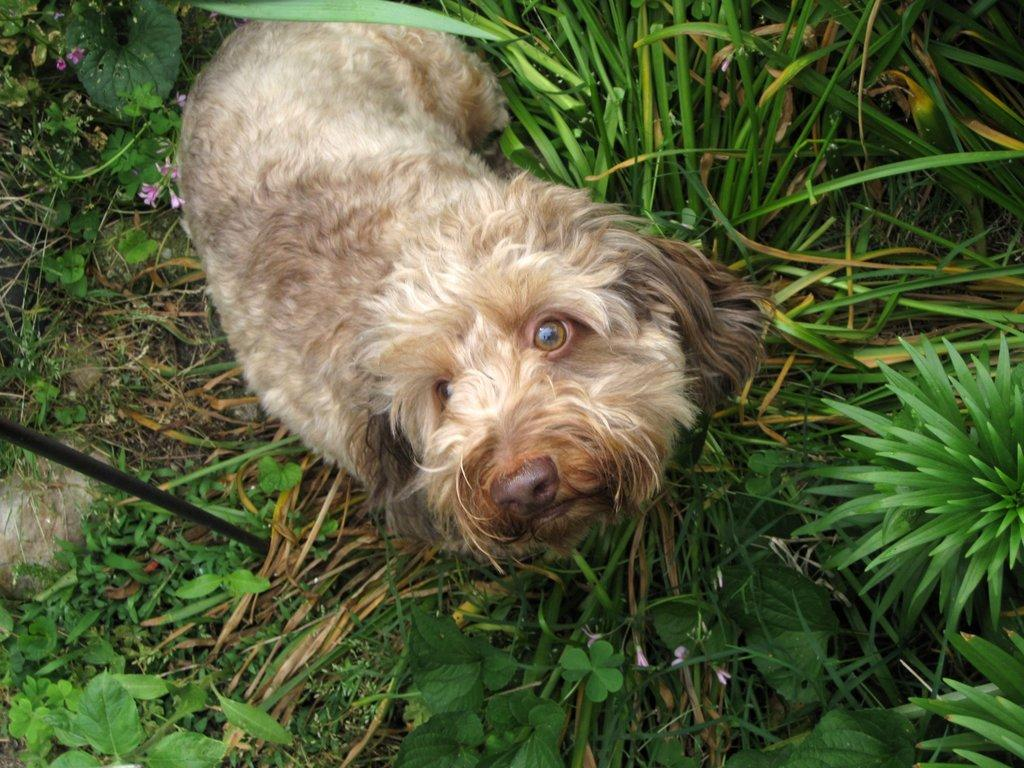What type of vegetation is present in the image? There is grass and plants on the ground in the image. What is the dog doing in the image? The dog is laying on the ground in the image. What is the dog looking at in the image? The dog is looking at the picture. What type of sheet is covering the dog in the image? There is no sheet covering the dog in the image; the dog is laying on the ground. What is the dog's desire in the image? The provided facts do not give any information about the dog's desires, so we cannot answer this question. 